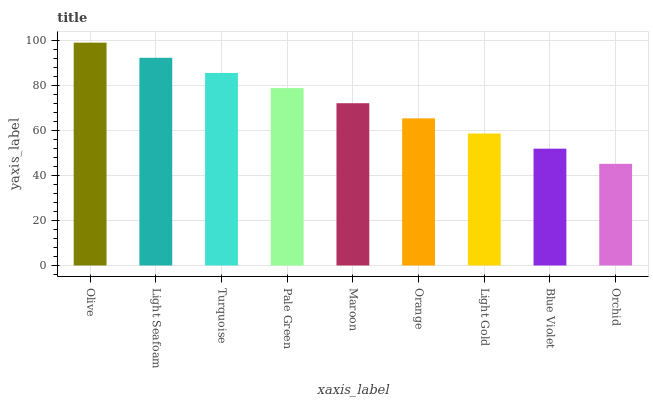Is Orchid the minimum?
Answer yes or no. Yes. Is Olive the maximum?
Answer yes or no. Yes. Is Light Seafoam the minimum?
Answer yes or no. No. Is Light Seafoam the maximum?
Answer yes or no. No. Is Olive greater than Light Seafoam?
Answer yes or no. Yes. Is Light Seafoam less than Olive?
Answer yes or no. Yes. Is Light Seafoam greater than Olive?
Answer yes or no. No. Is Olive less than Light Seafoam?
Answer yes or no. No. Is Maroon the high median?
Answer yes or no. Yes. Is Maroon the low median?
Answer yes or no. Yes. Is Turquoise the high median?
Answer yes or no. No. Is Blue Violet the low median?
Answer yes or no. No. 